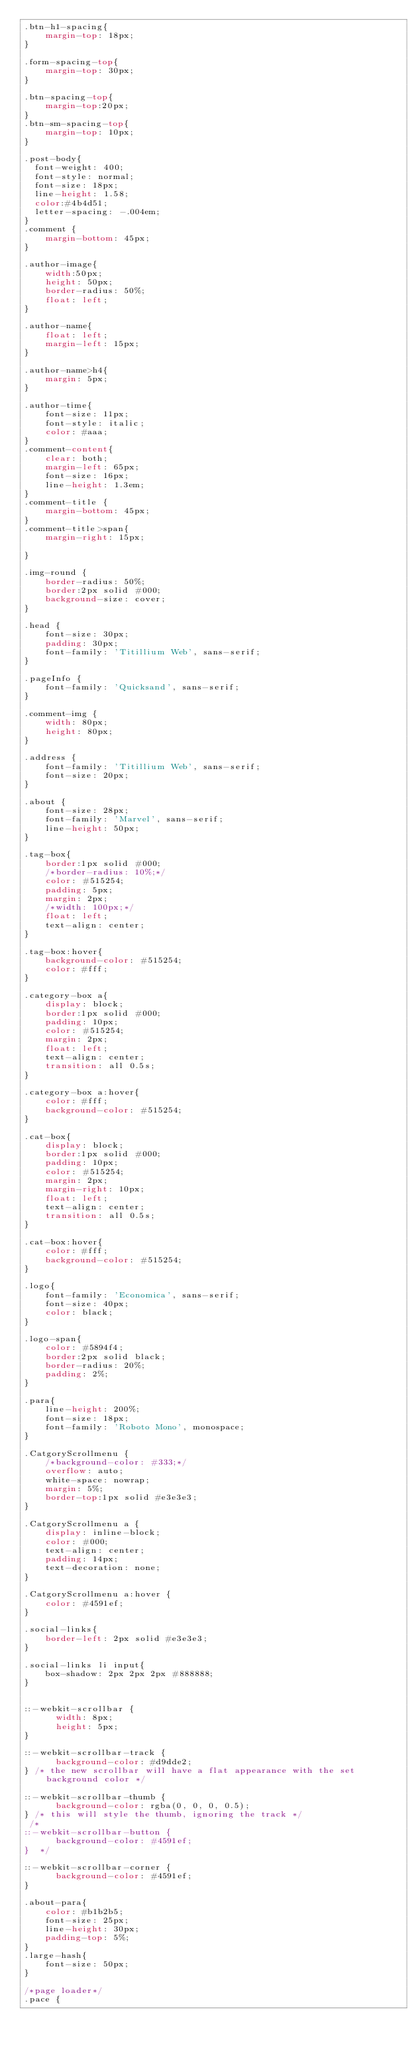<code> <loc_0><loc_0><loc_500><loc_500><_CSS_>.btn-h1-spacing{
	margin-top: 18px;
}

.form-spacing-top{
	margin-top: 30px;
}

.btn-spacing-top{
	margin-top:20px;
}
.btn-sm-spacing-top{
	margin-top: 10px;
}

.post-body{
  font-weight: 400;
  font-style: normal;
  font-size: 18px;
  line-height: 1.58;
  color:#4b4d51;
  letter-spacing: -.004em;
}
.comment {
	margin-bottom: 45px;
}

.author-image{
	width:50px;
	height: 50px;
	border-radius: 50%;
	float: left;
}

.author-name{
	float: left;
	margin-left: 15px;
}

.author-name>h4{
	margin: 5px;
}

.author-time{
	font-size: 11px;
	font-style: italic;
	color: #aaa;
}
.comment-content{
	clear: both;
	margin-left: 65px;
	font-size: 16px;
	line-height: 1.3em;
}
.comment-title {
	margin-bottom: 45px;
}
.comment-title>span{
	margin-right: 15px;

}

.img-round {
	border-radius: 50%;
	border:2px solid #000;
	background-size: cover;
}

.head {
	font-size: 30px;
	padding: 30px;
	font-family: 'Titillium Web', sans-serif;
}

.pageInfo {
	font-family: 'Quicksand', sans-serif;
}

.comment-img {
	width: 80px;
	height: 80px;
}

.address {
	font-family: 'Titillium Web', sans-serif;
	font-size: 20px;
}

.about {
	font-size: 28px;
	font-family: 'Marvel', sans-serif;
	line-height: 50px;
}

.tag-box{
	border:1px solid #000;
	/*border-radius: 10%;*/
	color: #515254;
	padding: 5px;
	margin: 2px;
	/*width: 100px;*/
	float: left;
	text-align: center;
}

.tag-box:hover{
	background-color: #515254;
	color: #fff;
}

.category-box a{
	display: block;
	border:1px solid #000;
	padding: 10px;
	color: #515254;
	margin: 2px;
	float: left;
	text-align: center;
	transition: all 0.5s;
}

.category-box a:hover{
	color: #fff;
	background-color: #515254;
}

.cat-box{
	display: block;
	border:1px solid #000;
	padding: 10px;
	color: #515254;
	margin: 2px;
	margin-right: 10px;
	float: left;
	text-align: center;
	transition: all 0.5s;
}

.cat-box:hover{
	color: #fff;
	background-color: #515254;
}

.logo{
	font-family: 'Economica', sans-serif;
	font-size: 40px;
	color: black;
}

.logo-span{
	color: #5894f4;
	border:2px solid black; 
	border-radius: 20%; 
	padding: 2%;
}

.para{
	line-height: 200%;
	font-size: 18px;
	font-family: 'Roboto Mono', monospace;
}

.CatgoryScrollmenu {
    /*background-color: #333;*/
    overflow: auto;
    white-space: nowrap;
    margin: 5%;
    border-top:1px solid #e3e3e3;
}

.CatgoryScrollmenu a {
    display: inline-block;
    color: #000;
    text-align: center;
    padding: 14px;
    text-decoration: none;
}

.CatgoryScrollmenu a:hover {
    color: #4591ef;
}

.social-links{
	border-left: 2px solid #e3e3e3;
}

.social-links li input{
	box-shadow: 2px 2px 2px #888888;
}


::-webkit-scrollbar {
      width: 8px;
      height: 5px;
}

::-webkit-scrollbar-track {
      background-color: #d9dde2;
} /* the new scrollbar will have a flat appearance with the set background color */
 
::-webkit-scrollbar-thumb {
      background-color: rgba(0, 0, 0, 0.5); 
} /* this will style the thumb, ignoring the track */
 /*
::-webkit-scrollbar-button {
      background-color: #4591ef;
}  */
 
::-webkit-scrollbar-corner {
      background-color: #4591ef;
} 

.about-para{
	color: #b1b2b5;
	font-size: 25px;
	line-height: 30px;
	padding-top: 5%;
}
.large-hash{
	font-size: 50px;
}

/*page loader*/
.pace {</code> 